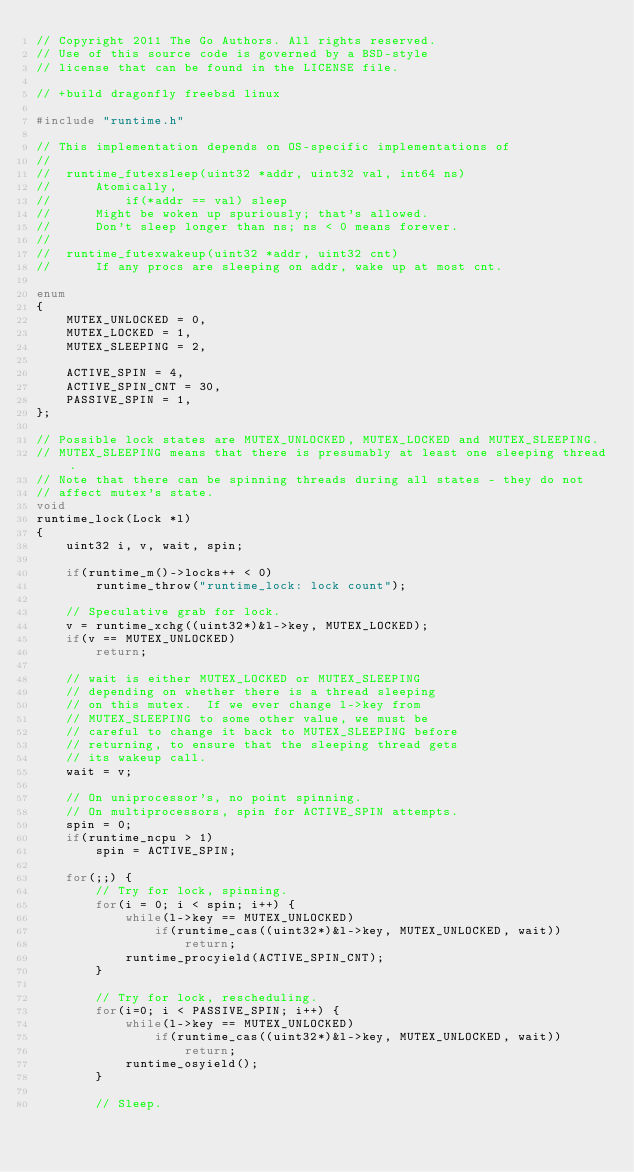<code> <loc_0><loc_0><loc_500><loc_500><_C_>// Copyright 2011 The Go Authors. All rights reserved.
// Use of this source code is governed by a BSD-style
// license that can be found in the LICENSE file.

// +build dragonfly freebsd linux

#include "runtime.h"

// This implementation depends on OS-specific implementations of
//
//	runtime_futexsleep(uint32 *addr, uint32 val, int64 ns)
//		Atomically,
//			if(*addr == val) sleep
//		Might be woken up spuriously; that's allowed.
//		Don't sleep longer than ns; ns < 0 means forever.
//
//	runtime_futexwakeup(uint32 *addr, uint32 cnt)
//		If any procs are sleeping on addr, wake up at most cnt.

enum
{
	MUTEX_UNLOCKED = 0,
	MUTEX_LOCKED = 1,
	MUTEX_SLEEPING = 2,

	ACTIVE_SPIN = 4,
	ACTIVE_SPIN_CNT = 30,
	PASSIVE_SPIN = 1,
};

// Possible lock states are MUTEX_UNLOCKED, MUTEX_LOCKED and MUTEX_SLEEPING.
// MUTEX_SLEEPING means that there is presumably at least one sleeping thread.
// Note that there can be spinning threads during all states - they do not
// affect mutex's state.
void
runtime_lock(Lock *l)
{
	uint32 i, v, wait, spin;

	if(runtime_m()->locks++ < 0)
		runtime_throw("runtime_lock: lock count");

	// Speculative grab for lock.
	v = runtime_xchg((uint32*)&l->key, MUTEX_LOCKED);
	if(v == MUTEX_UNLOCKED)
		return;

	// wait is either MUTEX_LOCKED or MUTEX_SLEEPING
	// depending on whether there is a thread sleeping
	// on this mutex.  If we ever change l->key from
	// MUTEX_SLEEPING to some other value, we must be
	// careful to change it back to MUTEX_SLEEPING before
	// returning, to ensure that the sleeping thread gets
	// its wakeup call.
	wait = v;

	// On uniprocessor's, no point spinning.
	// On multiprocessors, spin for ACTIVE_SPIN attempts.
	spin = 0;
	if(runtime_ncpu > 1)
		spin = ACTIVE_SPIN;

	for(;;) {
		// Try for lock, spinning.
		for(i = 0; i < spin; i++) {
			while(l->key == MUTEX_UNLOCKED)
				if(runtime_cas((uint32*)&l->key, MUTEX_UNLOCKED, wait))
					return;
			runtime_procyield(ACTIVE_SPIN_CNT);
		}

		// Try for lock, rescheduling.
		for(i=0; i < PASSIVE_SPIN; i++) {
			while(l->key == MUTEX_UNLOCKED)
				if(runtime_cas((uint32*)&l->key, MUTEX_UNLOCKED, wait))
					return;
			runtime_osyield();
		}

		// Sleep.</code> 